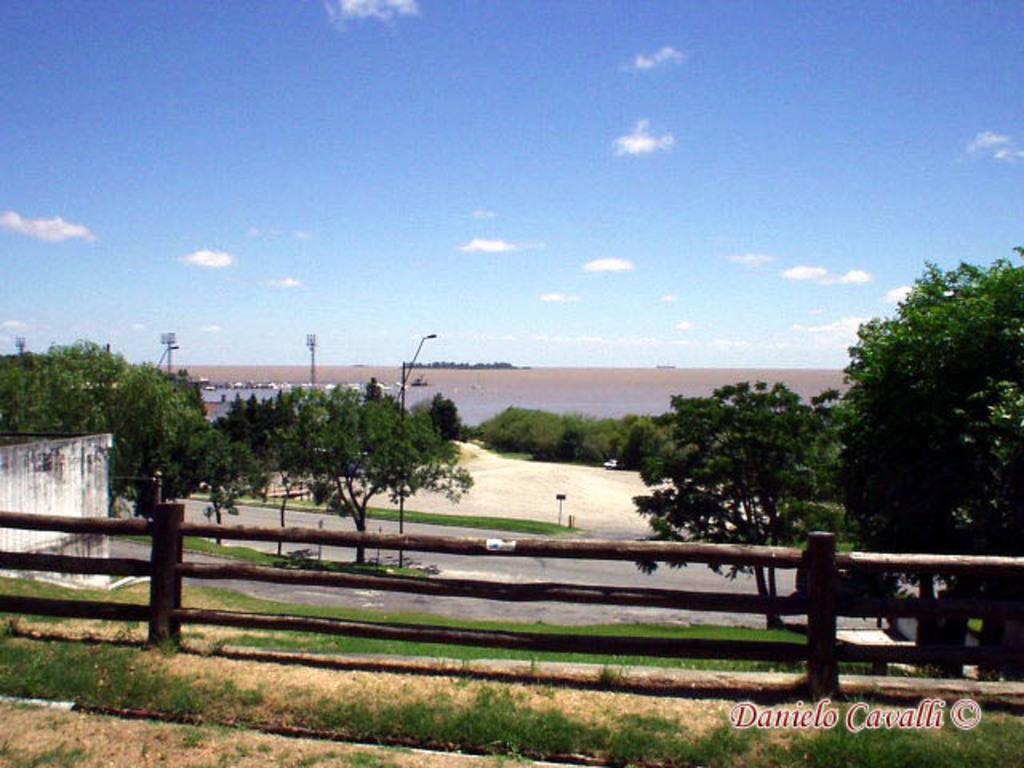Could you give a brief overview of what you see in this image? In this image we can see sky with clouds, sea, road, trees, street poles, street lights, wooden fence and ground. 